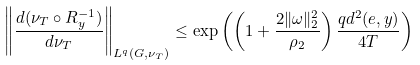<formula> <loc_0><loc_0><loc_500><loc_500>\left \| \frac { d ( \nu _ { T } \circ R _ { y } ^ { - 1 } ) } { d \nu _ { T } } \right \| _ { L ^ { q } ( G , \nu _ { T } ) } \leq \exp \left ( \left ( 1 + \frac { 2 \| \omega \| _ { 2 } ^ { 2 } } { \rho _ { 2 } } \right ) \frac { q d ^ { 2 } ( e , y ) } { 4 T } \right )</formula> 